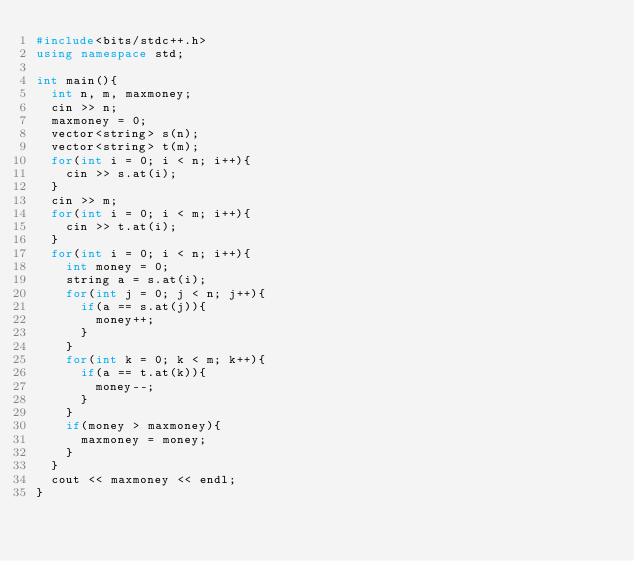<code> <loc_0><loc_0><loc_500><loc_500><_C++_>#include<bits/stdc++.h>
using namespace std;

int main(){
  int n, m, maxmoney;
  cin >> n;
  maxmoney = 0;
  vector<string> s(n);
  vector<string> t(m);
  for(int i = 0; i < n; i++){
    cin >> s.at(i);
  }
  cin >> m;
  for(int i = 0; i < m; i++){
    cin >> t.at(i);
  }
  for(int i = 0; i < n; i++){
    int money = 0;
    string a = s.at(i);
    for(int j = 0; j < n; j++){
      if(a == s.at(j)){
        money++;
      }
    }
    for(int k = 0; k < m; k++){
      if(a == t.at(k)){
        money--;
      }
    }
    if(money > maxmoney){
      maxmoney = money;
    }
  }
  cout << maxmoney << endl;
}</code> 